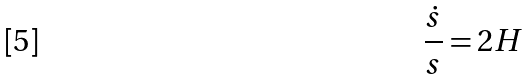<formula> <loc_0><loc_0><loc_500><loc_500>\frac { \dot { s } } { s } = 2 H</formula> 